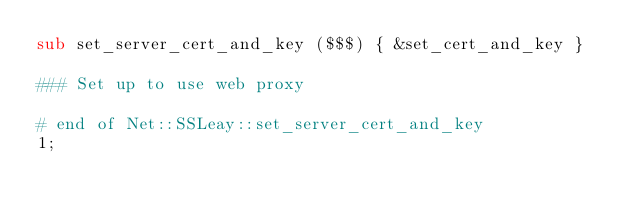<code> <loc_0><loc_0><loc_500><loc_500><_Perl_>sub set_server_cert_and_key ($$$) { &set_cert_and_key }

### Set up to use web proxy

# end of Net::SSLeay::set_server_cert_and_key
1;
</code> 